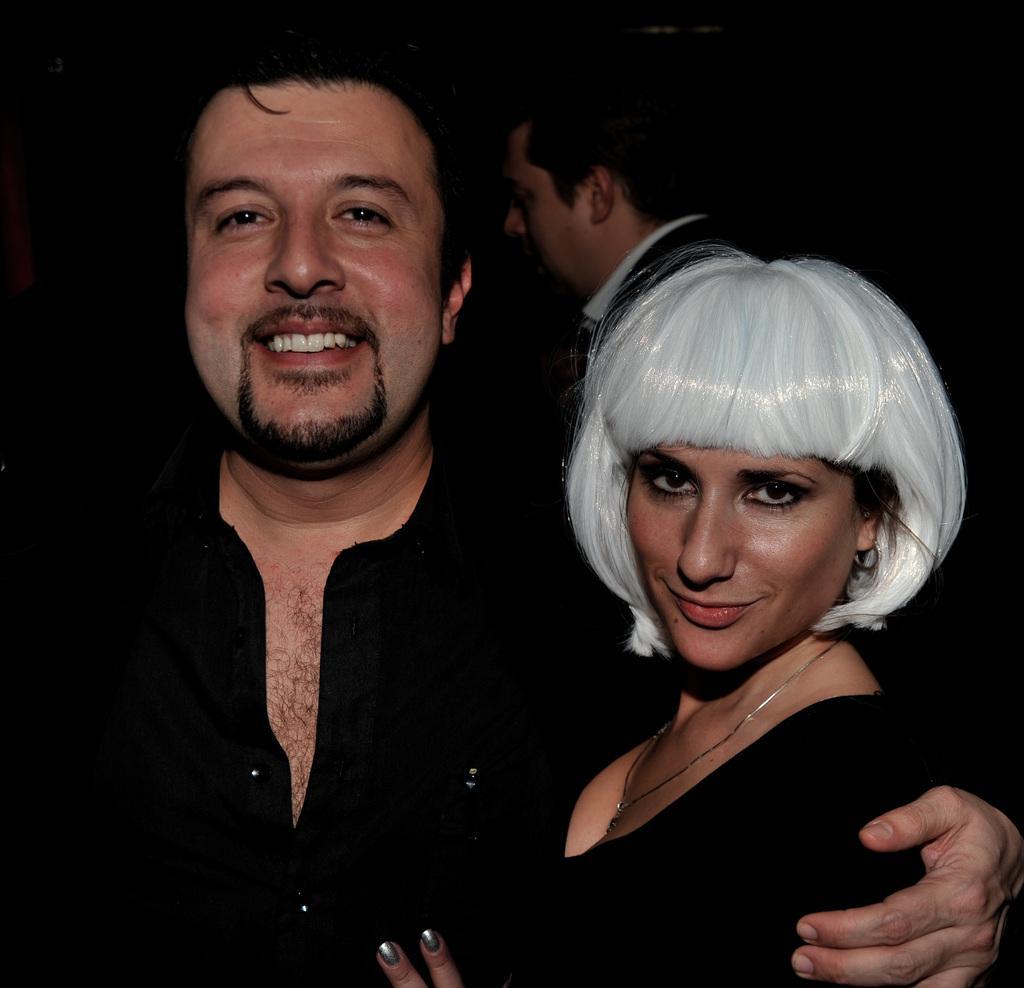How would you summarize this image in a sentence or two? In this picture there are two persons standing and smiling and the woman has a white hair. At the back there is a person standing. 